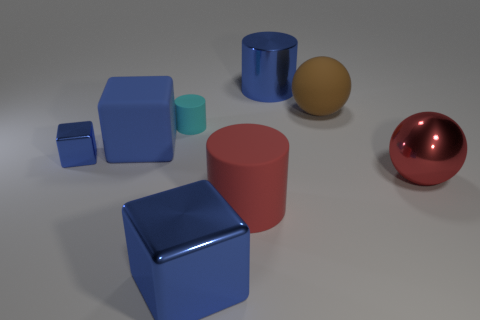Subtract 1 cylinders. How many cylinders are left? 2 Add 2 big blue rubber things. How many objects exist? 10 Subtract all balls. How many objects are left? 6 Add 2 large red cylinders. How many large red cylinders exist? 3 Subtract 0 red cubes. How many objects are left? 8 Subtract all big balls. Subtract all rubber objects. How many objects are left? 2 Add 1 large matte cubes. How many large matte cubes are left? 2 